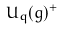<formula> <loc_0><loc_0><loc_500><loc_500>U _ { q } ( g ) ^ { + }</formula> 